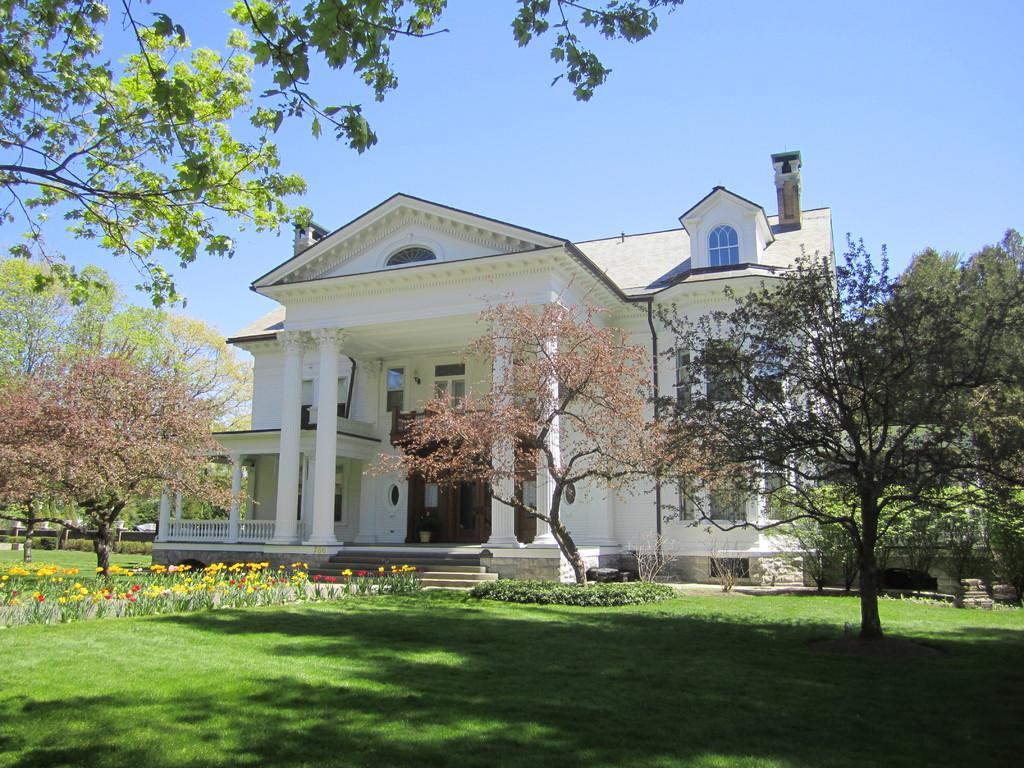Please provide a concise description of this image. This image consists of a building in white color. At the bottom, there is green grass. On the left, we can see flowers in yellow and red colors. In the front, there are trees. At the top, there is sky. 